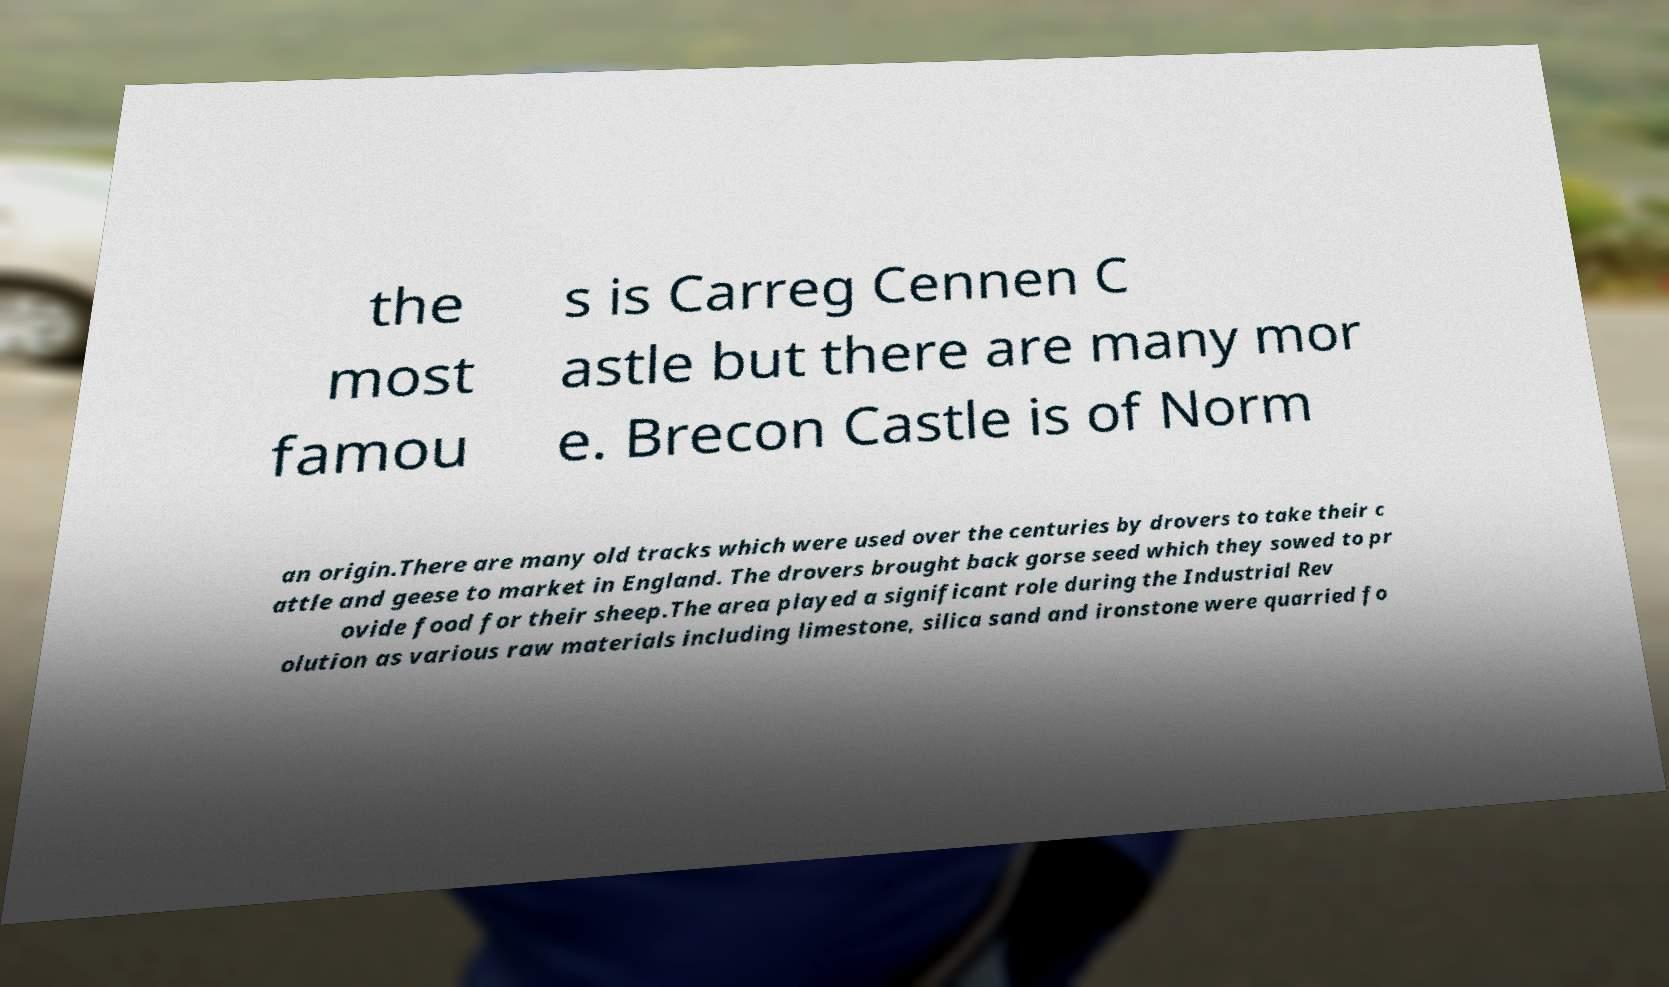There's text embedded in this image that I need extracted. Can you transcribe it verbatim? the most famou s is Carreg Cennen C astle but there are many mor e. Brecon Castle is of Norm an origin.There are many old tracks which were used over the centuries by drovers to take their c attle and geese to market in England. The drovers brought back gorse seed which they sowed to pr ovide food for their sheep.The area played a significant role during the Industrial Rev olution as various raw materials including limestone, silica sand and ironstone were quarried fo 